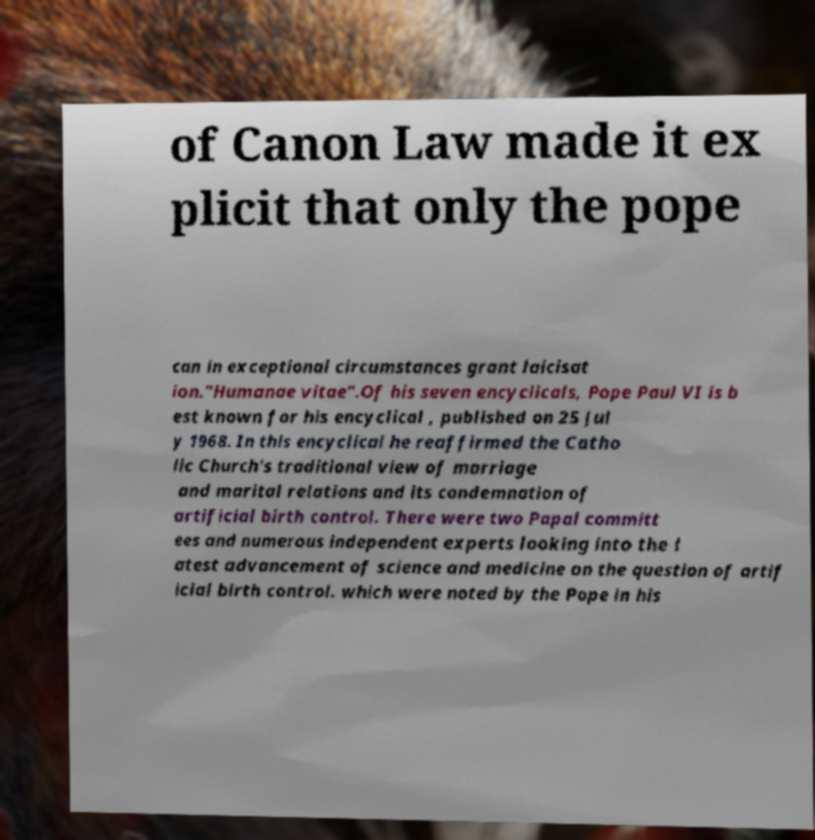Could you assist in decoding the text presented in this image and type it out clearly? of Canon Law made it ex plicit that only the pope can in exceptional circumstances grant laicisat ion."Humanae vitae".Of his seven encyclicals, Pope Paul VI is b est known for his encyclical , published on 25 Jul y 1968. In this encyclical he reaffirmed the Catho lic Church's traditional view of marriage and marital relations and its condemnation of artificial birth control. There were two Papal committ ees and numerous independent experts looking into the l atest advancement of science and medicine on the question of artif icial birth control. which were noted by the Pope in his 